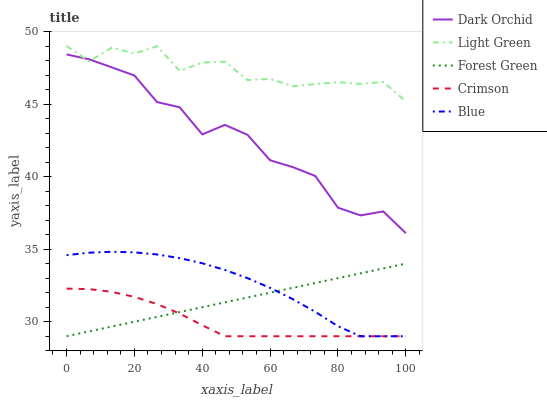Does Crimson have the minimum area under the curve?
Answer yes or no. Yes. Does Light Green have the maximum area under the curve?
Answer yes or no. Yes. Does Blue have the minimum area under the curve?
Answer yes or no. No. Does Blue have the maximum area under the curve?
Answer yes or no. No. Is Forest Green the smoothest?
Answer yes or no. Yes. Is Dark Orchid the roughest?
Answer yes or no. Yes. Is Blue the smoothest?
Answer yes or no. No. Is Blue the roughest?
Answer yes or no. No. Does Crimson have the lowest value?
Answer yes or no. Yes. Does Light Green have the lowest value?
Answer yes or no. No. Does Light Green have the highest value?
Answer yes or no. Yes. Does Blue have the highest value?
Answer yes or no. No. Is Crimson less than Dark Orchid?
Answer yes or no. Yes. Is Dark Orchid greater than Crimson?
Answer yes or no. Yes. Does Blue intersect Crimson?
Answer yes or no. Yes. Is Blue less than Crimson?
Answer yes or no. No. Is Blue greater than Crimson?
Answer yes or no. No. Does Crimson intersect Dark Orchid?
Answer yes or no. No. 